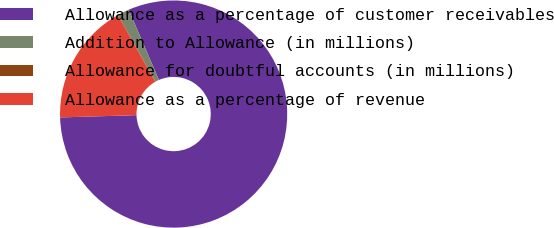Convert chart. <chart><loc_0><loc_0><loc_500><loc_500><pie_chart><fcel>Allowance as a percentage of customer receivables<fcel>Addition to Allowance (in millions)<fcel>Allowance for doubtful accounts (in millions)<fcel>Allowance as a percentage of revenue<nl><fcel>81.0%<fcel>1.63%<fcel>0.09%<fcel>17.28%<nl></chart> 